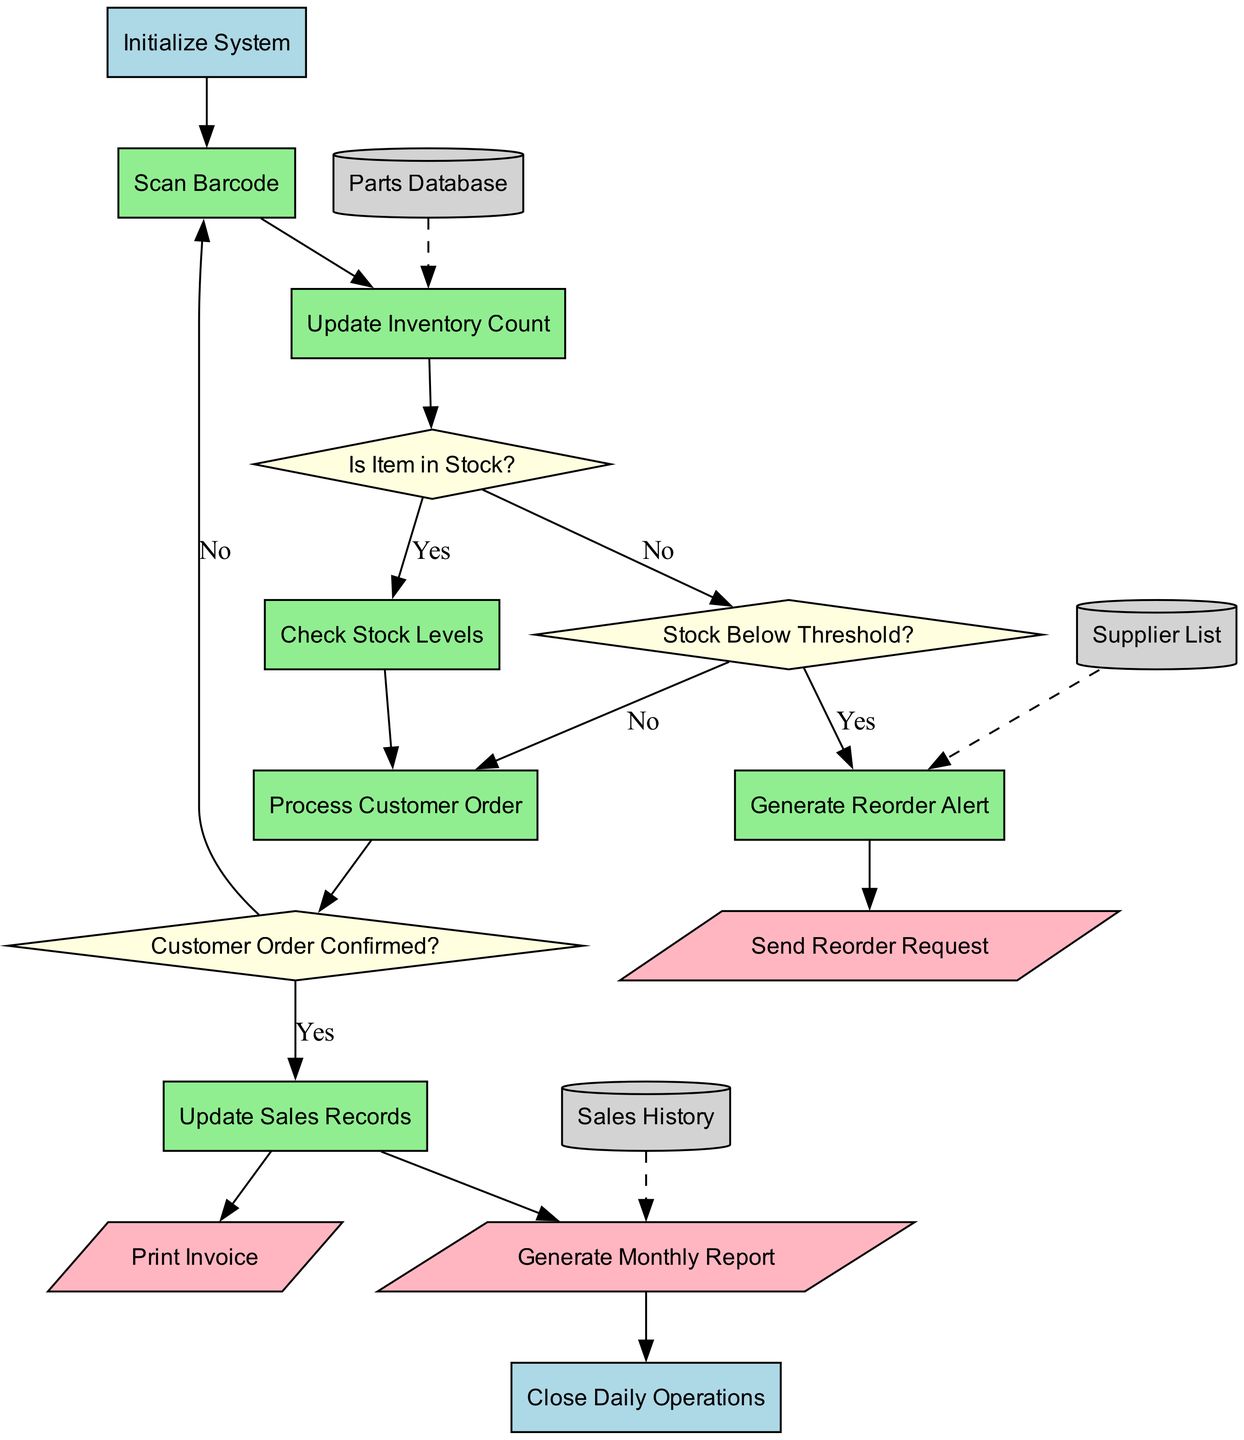What is the first process in the flowchart? The first process is identified directly after the initialization step and is labeled "Scan Barcode". Therefore, the connection leads from the start to this process.
Answer: Scan Barcode How many decision nodes are present in the diagram? The total number of decision nodes can be counted directly from the diagram's structure, where three diamond shapes are used to indicate decision points.
Answer: 3 What happens if the item is out of stock? If the item is out of stock, the flow goes from the decision node "Is Item in Stock?" to the next decision node "Stock Below Threshold?", indicating further checks take place before any actions like processing orders.
Answer: Check Stock Levels Which process comes after checking stock levels? The continuation from "Check Stock Levels" leads to a decision of whether the stock is below threshold. Thus, the sequence shows that checking the stock will result in either a reorder alert or processing a customer order.
Answer: Generate Reorder Alert What output is generated after processing a customer order? Following the process of "Update Sales Records", the flowchart indicates that the next node directly outputs a printed invoice. Thus, this connection clarifies the final action upon completing the customer order.
Answer: Print Invoice What data is connected to the "Update Inventory Count" process? The flowchart specifies a dashed line connecting the "Parts Database" to the "Update Inventory Count" process, indicating that this data is needed for that particular process.
Answer: Parts Database What is the last action depicted before closing daily operations? The diagram outlines that the final output generated before the end state is "Generate Monthly Report", showing that summarizing operations is the last step before concluding the process.
Answer: Generate Monthly Report If the customer order is not confirmed, what is the next action taken? When the customer order is not confirmed, the flow returns to the "Scan Barcode" process, indicating a loop to recommence the order preparation steps.
Answer: Scan Barcode Where does the "Send Reorder Request" output lead? This output leads directly to the end of the process, indicating that after generarating reorder requests, the system is completed. The connection shows the flow concluding after this output.
Answer: Close Daily Operations 